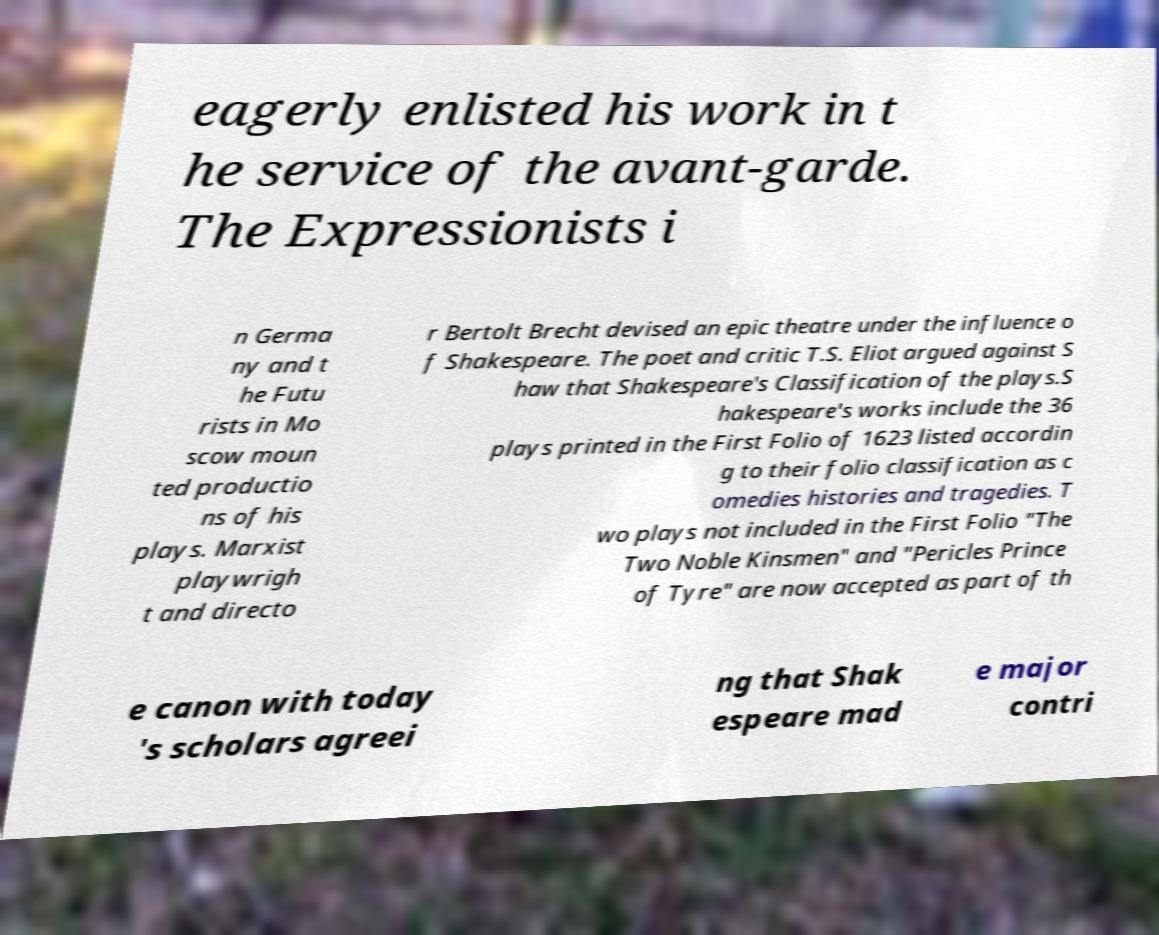Please identify and transcribe the text found in this image. eagerly enlisted his work in t he service of the avant-garde. The Expressionists i n Germa ny and t he Futu rists in Mo scow moun ted productio ns of his plays. Marxist playwrigh t and directo r Bertolt Brecht devised an epic theatre under the influence o f Shakespeare. The poet and critic T.S. Eliot argued against S haw that Shakespeare's Classification of the plays.S hakespeare's works include the 36 plays printed in the First Folio of 1623 listed accordin g to their folio classification as c omedies histories and tragedies. T wo plays not included in the First Folio "The Two Noble Kinsmen" and "Pericles Prince of Tyre" are now accepted as part of th e canon with today 's scholars agreei ng that Shak espeare mad e major contri 